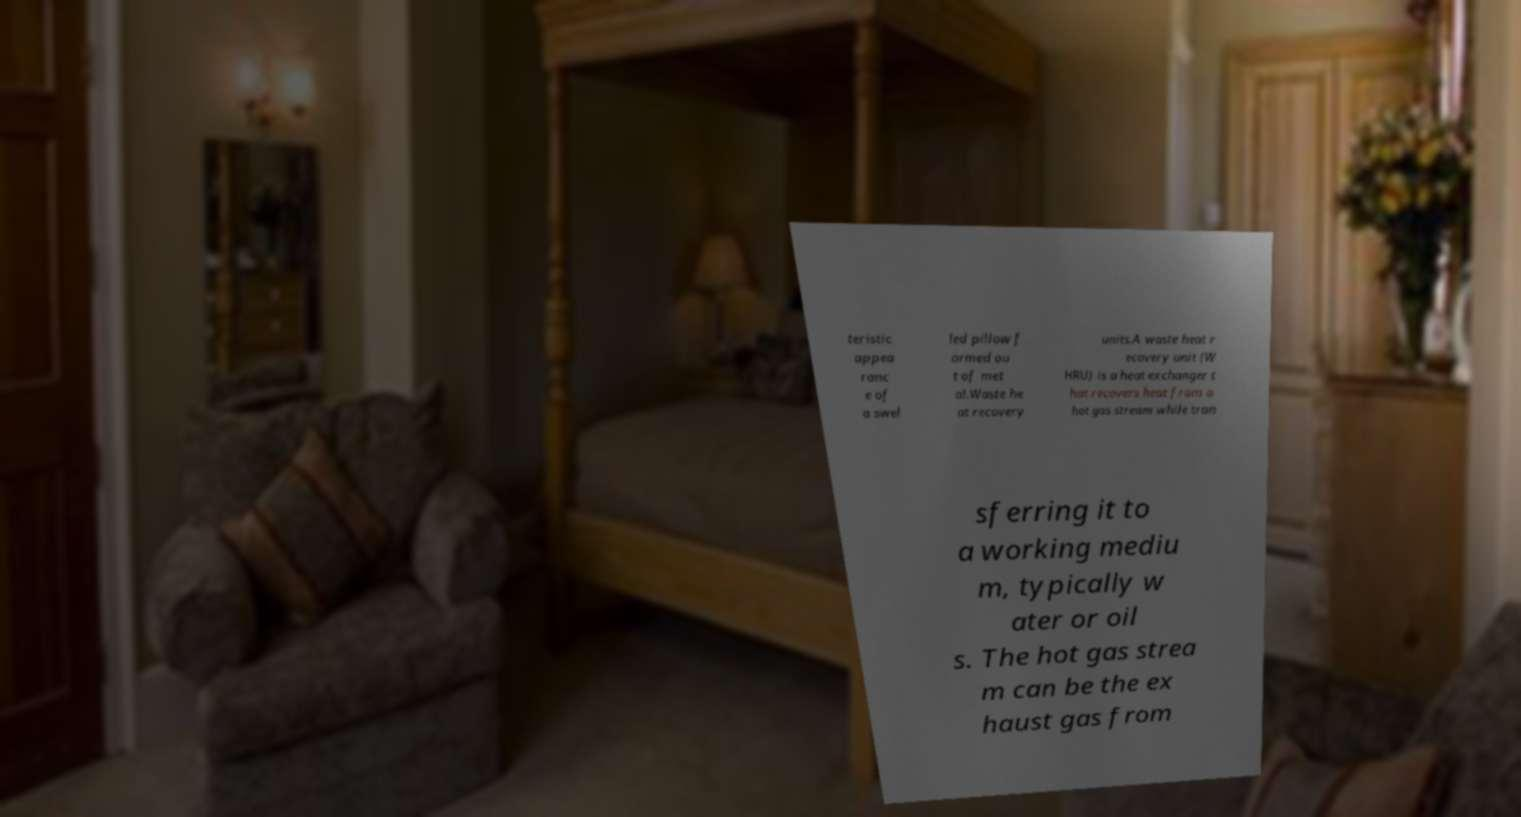Can you read and provide the text displayed in the image?This photo seems to have some interesting text. Can you extract and type it out for me? teristic appea ranc e of a swel led pillow f ormed ou t of met al.Waste he at recovery units.A waste heat r ecovery unit (W HRU) is a heat exchanger t hat recovers heat from a hot gas stream while tran sferring it to a working mediu m, typically w ater or oil s. The hot gas strea m can be the ex haust gas from 